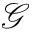Convert formula to latex. <formula><loc_0><loc_0><loc_500><loc_500>\mathcal { G }</formula> 